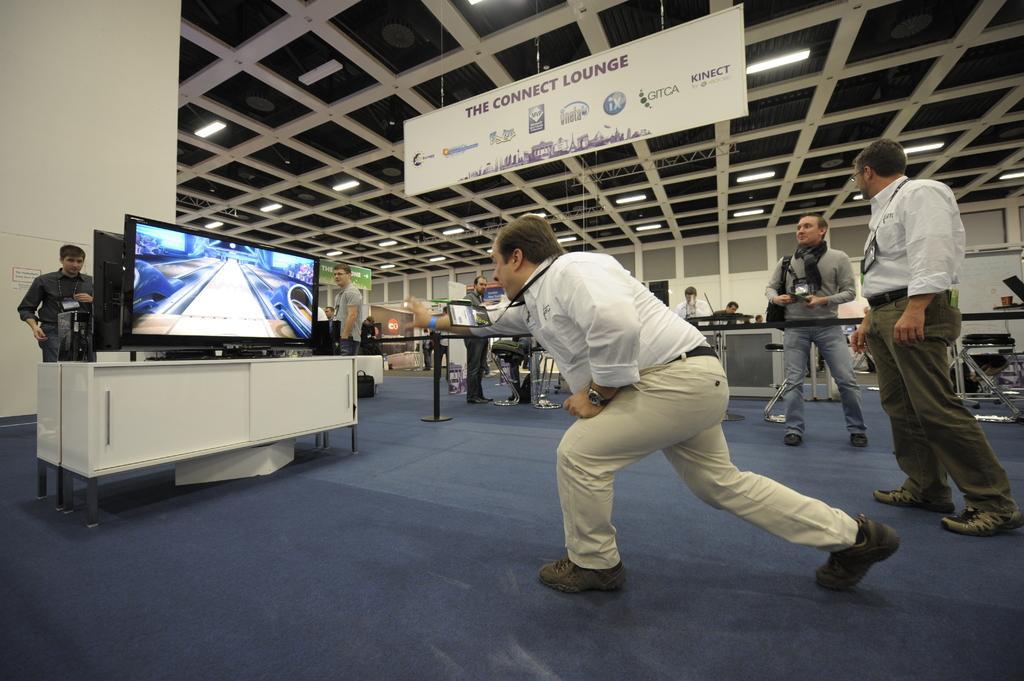Can you describe this image briefly? In the picture I can see a person wearing white shirt and there is a television which is placed on a table in front of him and there are two persons standing in the right corner and there is another television which has a person standing in front of it in the left corner and there are few other people and some other objects in the background. 